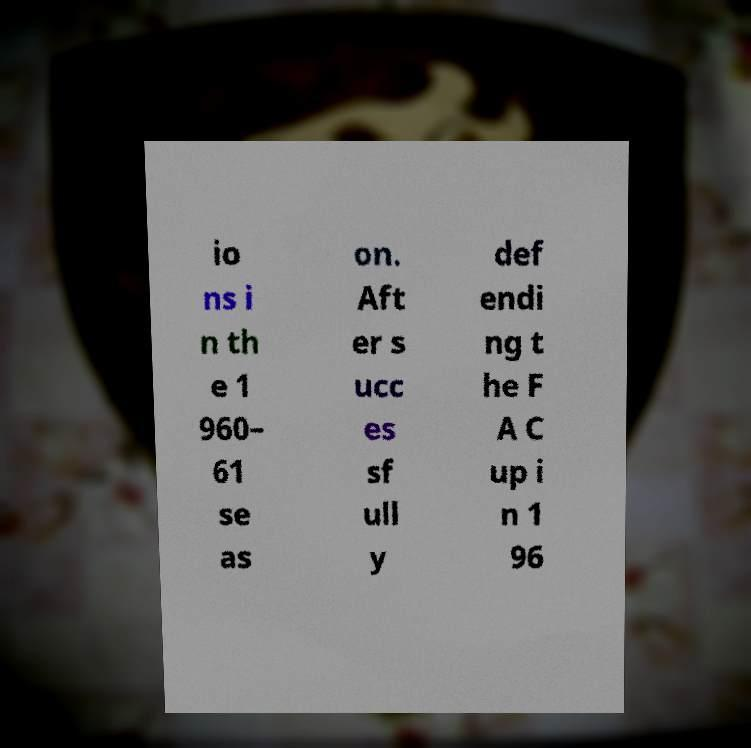Could you assist in decoding the text presented in this image and type it out clearly? io ns i n th e 1 960– 61 se as on. Aft er s ucc es sf ull y def endi ng t he F A C up i n 1 96 